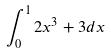<formula> <loc_0><loc_0><loc_500><loc_500>\int _ { 0 } ^ { 1 } 2 x ^ { 3 } + 3 d x</formula> 